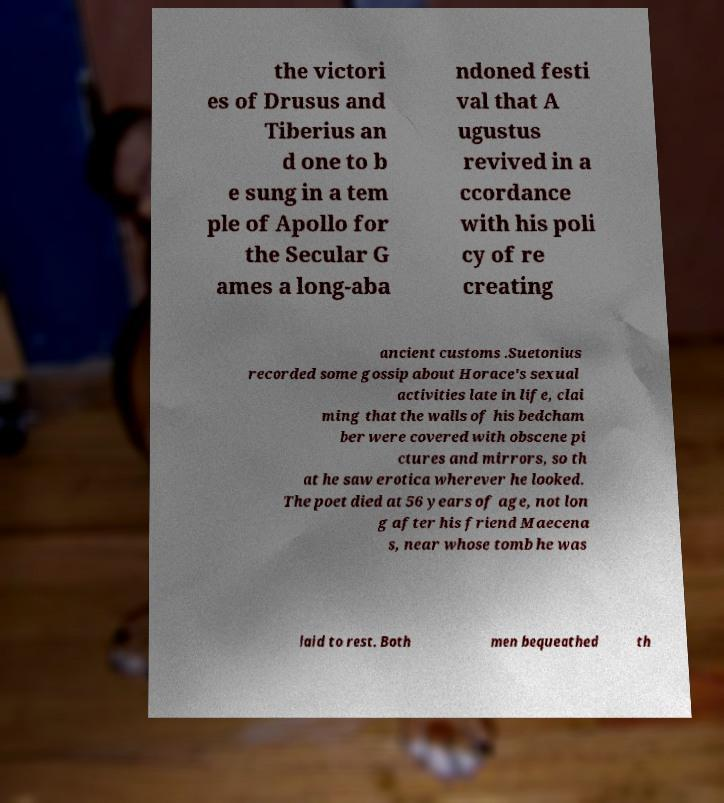For documentation purposes, I need the text within this image transcribed. Could you provide that? the victori es of Drusus and Tiberius an d one to b e sung in a tem ple of Apollo for the Secular G ames a long-aba ndoned festi val that A ugustus revived in a ccordance with his poli cy of re creating ancient customs .Suetonius recorded some gossip about Horace's sexual activities late in life, clai ming that the walls of his bedcham ber were covered with obscene pi ctures and mirrors, so th at he saw erotica wherever he looked. The poet died at 56 years of age, not lon g after his friend Maecena s, near whose tomb he was laid to rest. Both men bequeathed th 